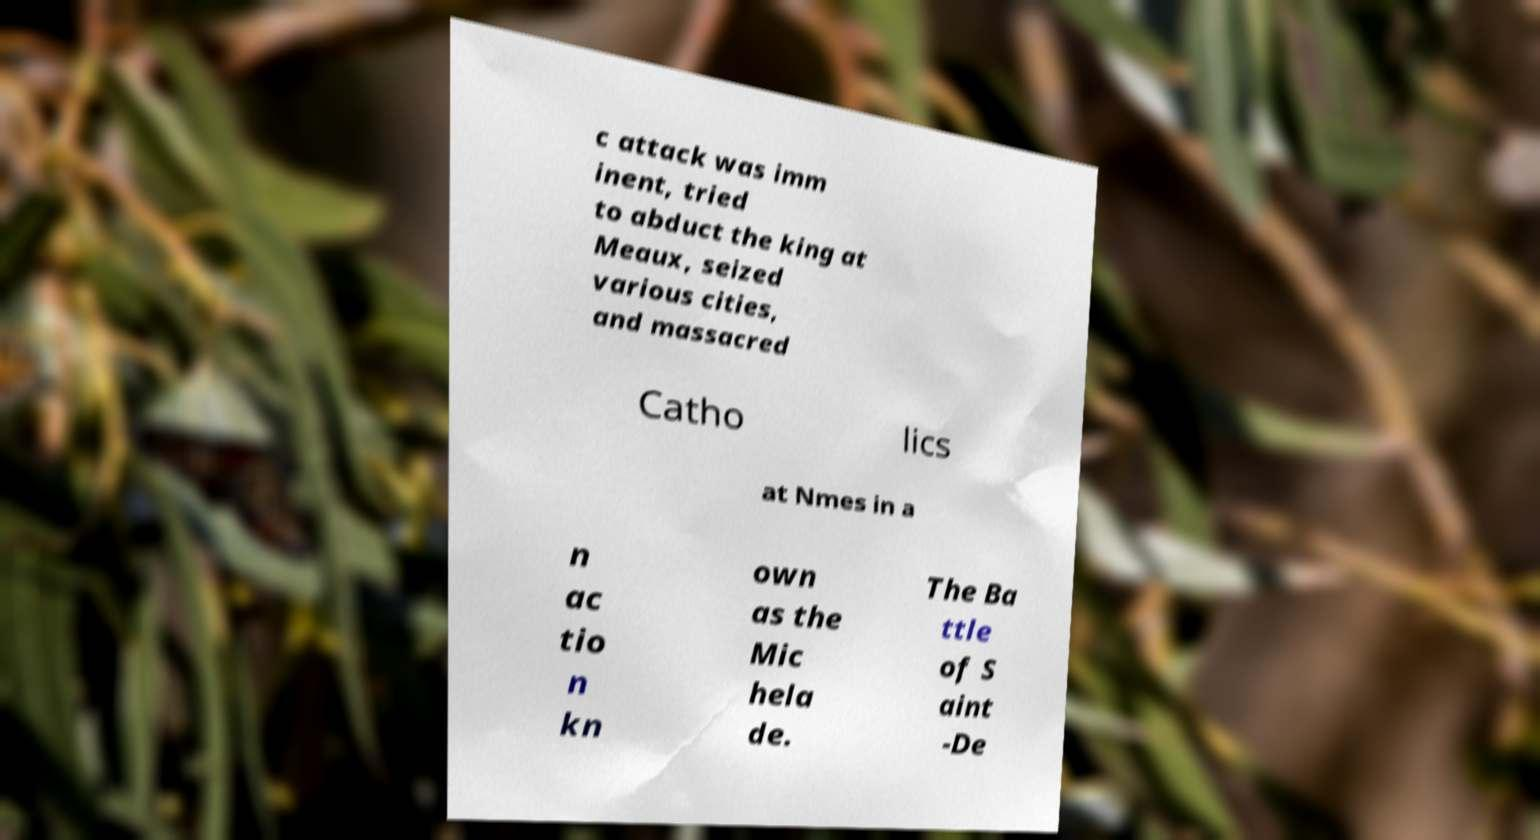What messages or text are displayed in this image? I need them in a readable, typed format. c attack was imm inent, tried to abduct the king at Meaux, seized various cities, and massacred Catho lics at Nmes in a n ac tio n kn own as the Mic hela de. The Ba ttle of S aint -De 